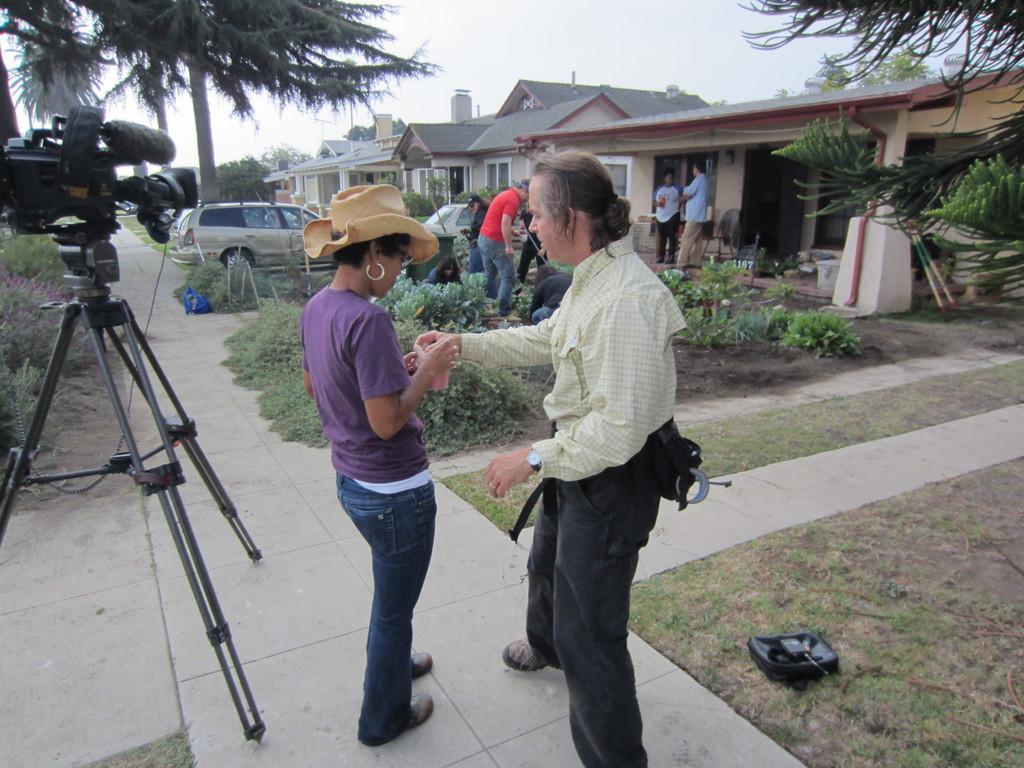In one or two sentences, can you explain what this image depicts? In this image there are people. On the left we can see a camera placed on the stand. There is a car. In the background there are trees and plants. At the top there is sky and we can see a building. 